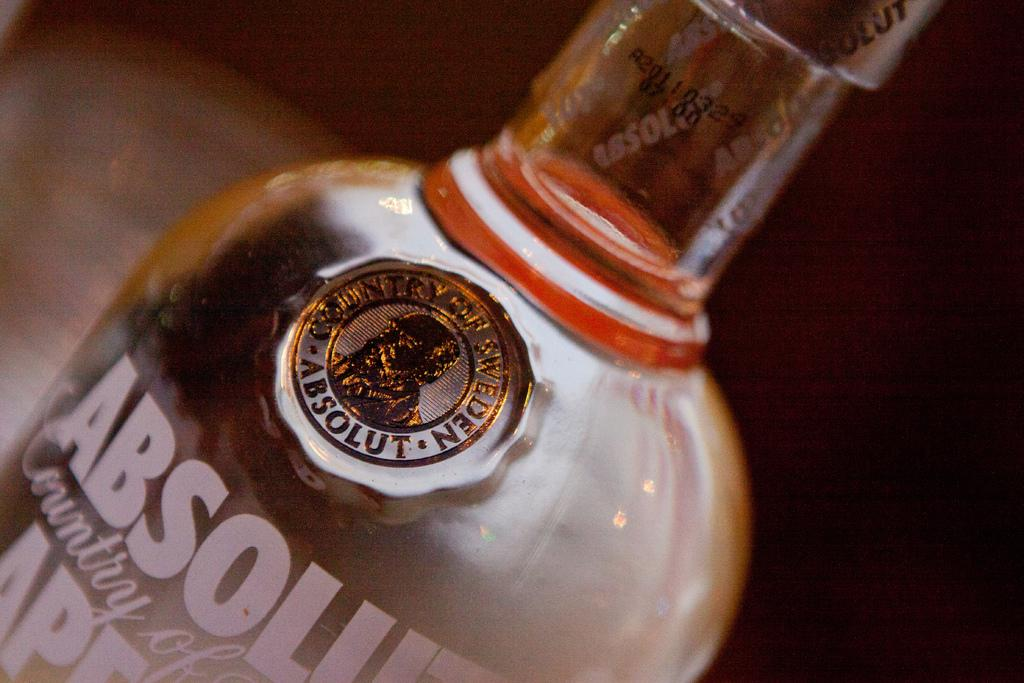Provide a one-sentence caption for the provided image. A bottle of Absolut vodka rests on a counter top. 